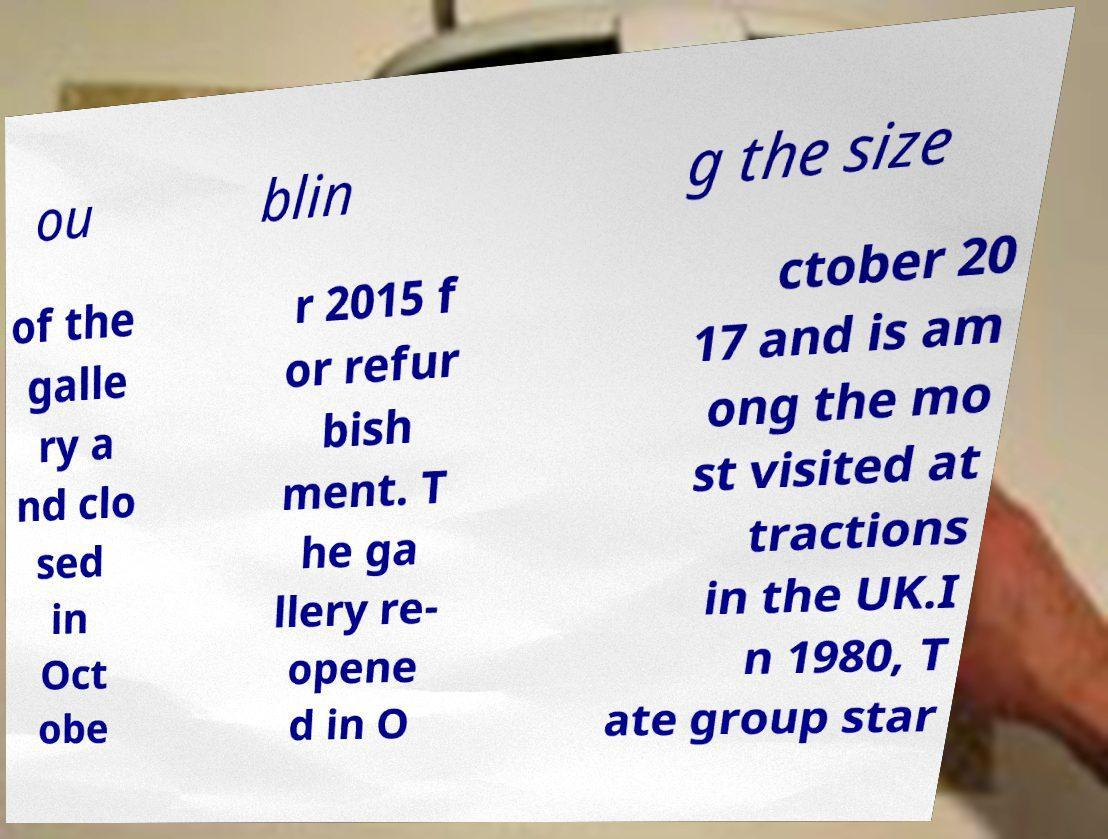Could you extract and type out the text from this image? ou blin g the size of the galle ry a nd clo sed in Oct obe r 2015 f or refur bish ment. T he ga llery re- opene d in O ctober 20 17 and is am ong the mo st visited at tractions in the UK.I n 1980, T ate group star 